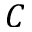Convert formula to latex. <formula><loc_0><loc_0><loc_500><loc_500>C</formula> 